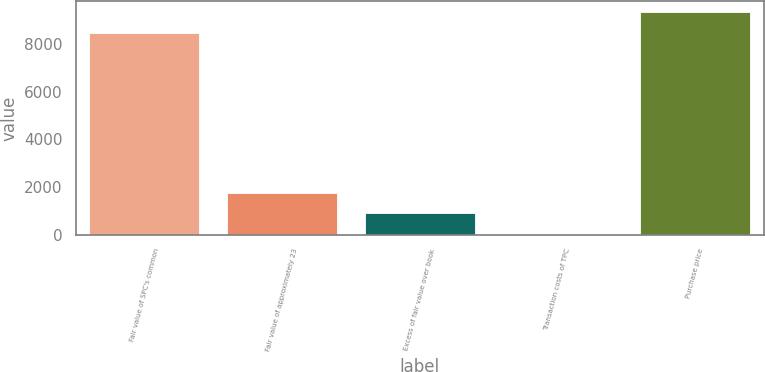<chart> <loc_0><loc_0><loc_500><loc_500><bar_chart><fcel>Fair value of SPC's common<fcel>Fair value of approximately 23<fcel>Excess of fair value over book<fcel>Transaction costs of TPC<fcel>Purchase price<nl><fcel>8452<fcel>1765.6<fcel>891.8<fcel>18<fcel>9325.8<nl></chart> 